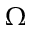Convert formula to latex. <formula><loc_0><loc_0><loc_500><loc_500>\Omega</formula> 